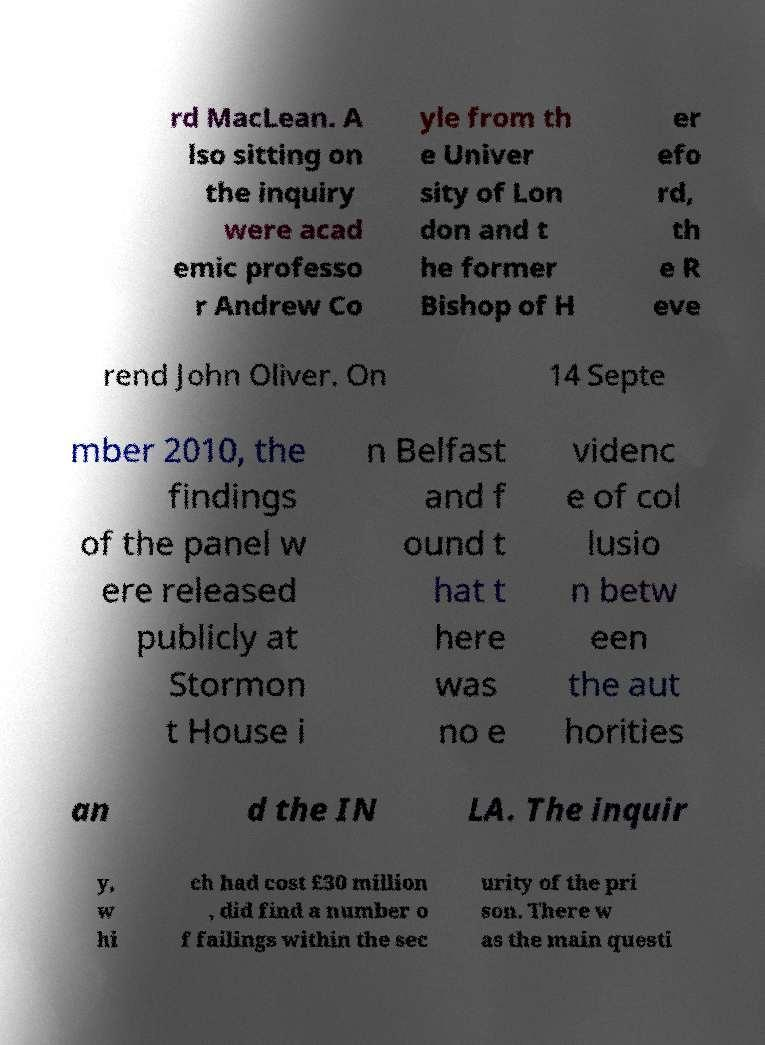Can you read and provide the text displayed in the image?This photo seems to have some interesting text. Can you extract and type it out for me? rd MacLean. A lso sitting on the inquiry were acad emic professo r Andrew Co yle from th e Univer sity of Lon don and t he former Bishop of H er efo rd, th e R eve rend John Oliver. On 14 Septe mber 2010, the findings of the panel w ere released publicly at Stormon t House i n Belfast and f ound t hat t here was no e videnc e of col lusio n betw een the aut horities an d the IN LA. The inquir y, w hi ch had cost £30 million , did find a number o f failings within the sec urity of the pri son. There w as the main questi 